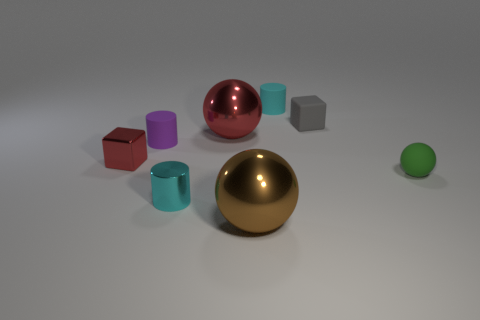The tiny green thing has what shape?
Make the answer very short. Sphere. Is the number of matte objects on the left side of the tiny gray rubber thing greater than the number of large cyan matte blocks?
Give a very brief answer. Yes. What is the shape of the tiny green rubber thing that is right of the purple cylinder?
Provide a short and direct response. Sphere. What number of other things are there of the same shape as the cyan rubber object?
Provide a short and direct response. 2. Is the ball behind the purple thing made of the same material as the tiny gray cube?
Give a very brief answer. No. Is the number of objects behind the red sphere the same as the number of metallic things in front of the tiny green matte thing?
Offer a terse response. Yes. How big is the metal ball that is behind the cyan metallic thing?
Provide a short and direct response. Large. Is there a large brown thing made of the same material as the brown sphere?
Ensure brevity in your answer.  No. There is a large object behind the shiny cube; is it the same color as the tiny shiny block?
Provide a succinct answer. Yes. Are there the same number of red shiny things right of the small rubber ball and purple objects?
Your response must be concise. No. 